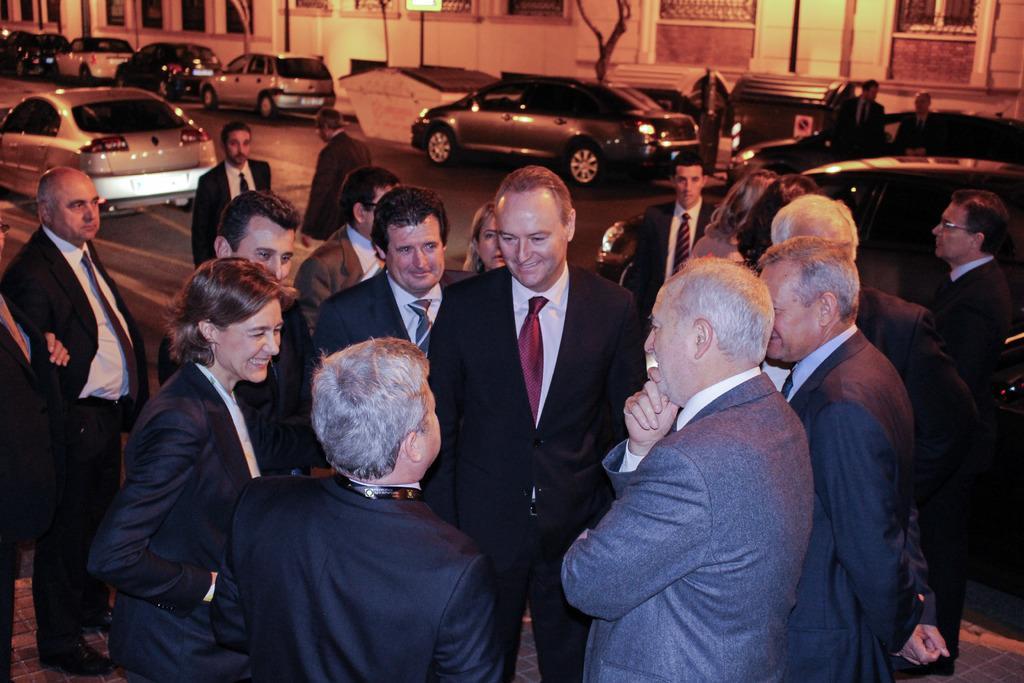Describe this image in one or two sentences. In this image in the foreground there is a crowd standing on the road, on the road there are few vehicles, peoples visible, at the top there are building, trunk of tree, pole visible. 